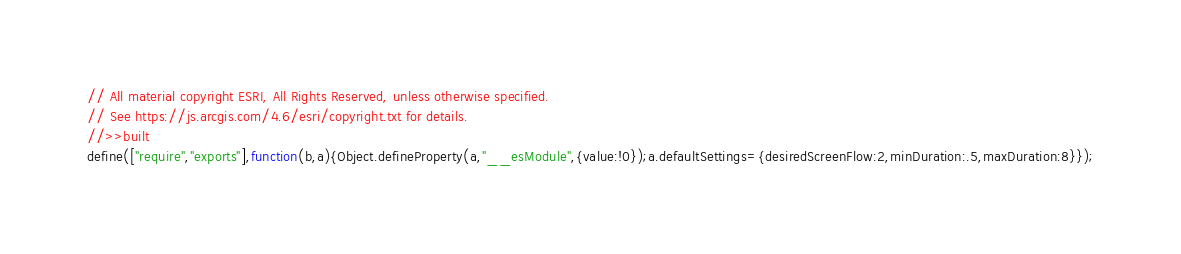Convert code to text. <code><loc_0><loc_0><loc_500><loc_500><_JavaScript_>// All material copyright ESRI, All Rights Reserved, unless otherwise specified.
// See https://js.arcgis.com/4.6/esri/copyright.txt for details.
//>>built
define(["require","exports"],function(b,a){Object.defineProperty(a,"__esModule",{value:!0});a.defaultSettings={desiredScreenFlow:2,minDuration:.5,maxDuration:8}});</code> 